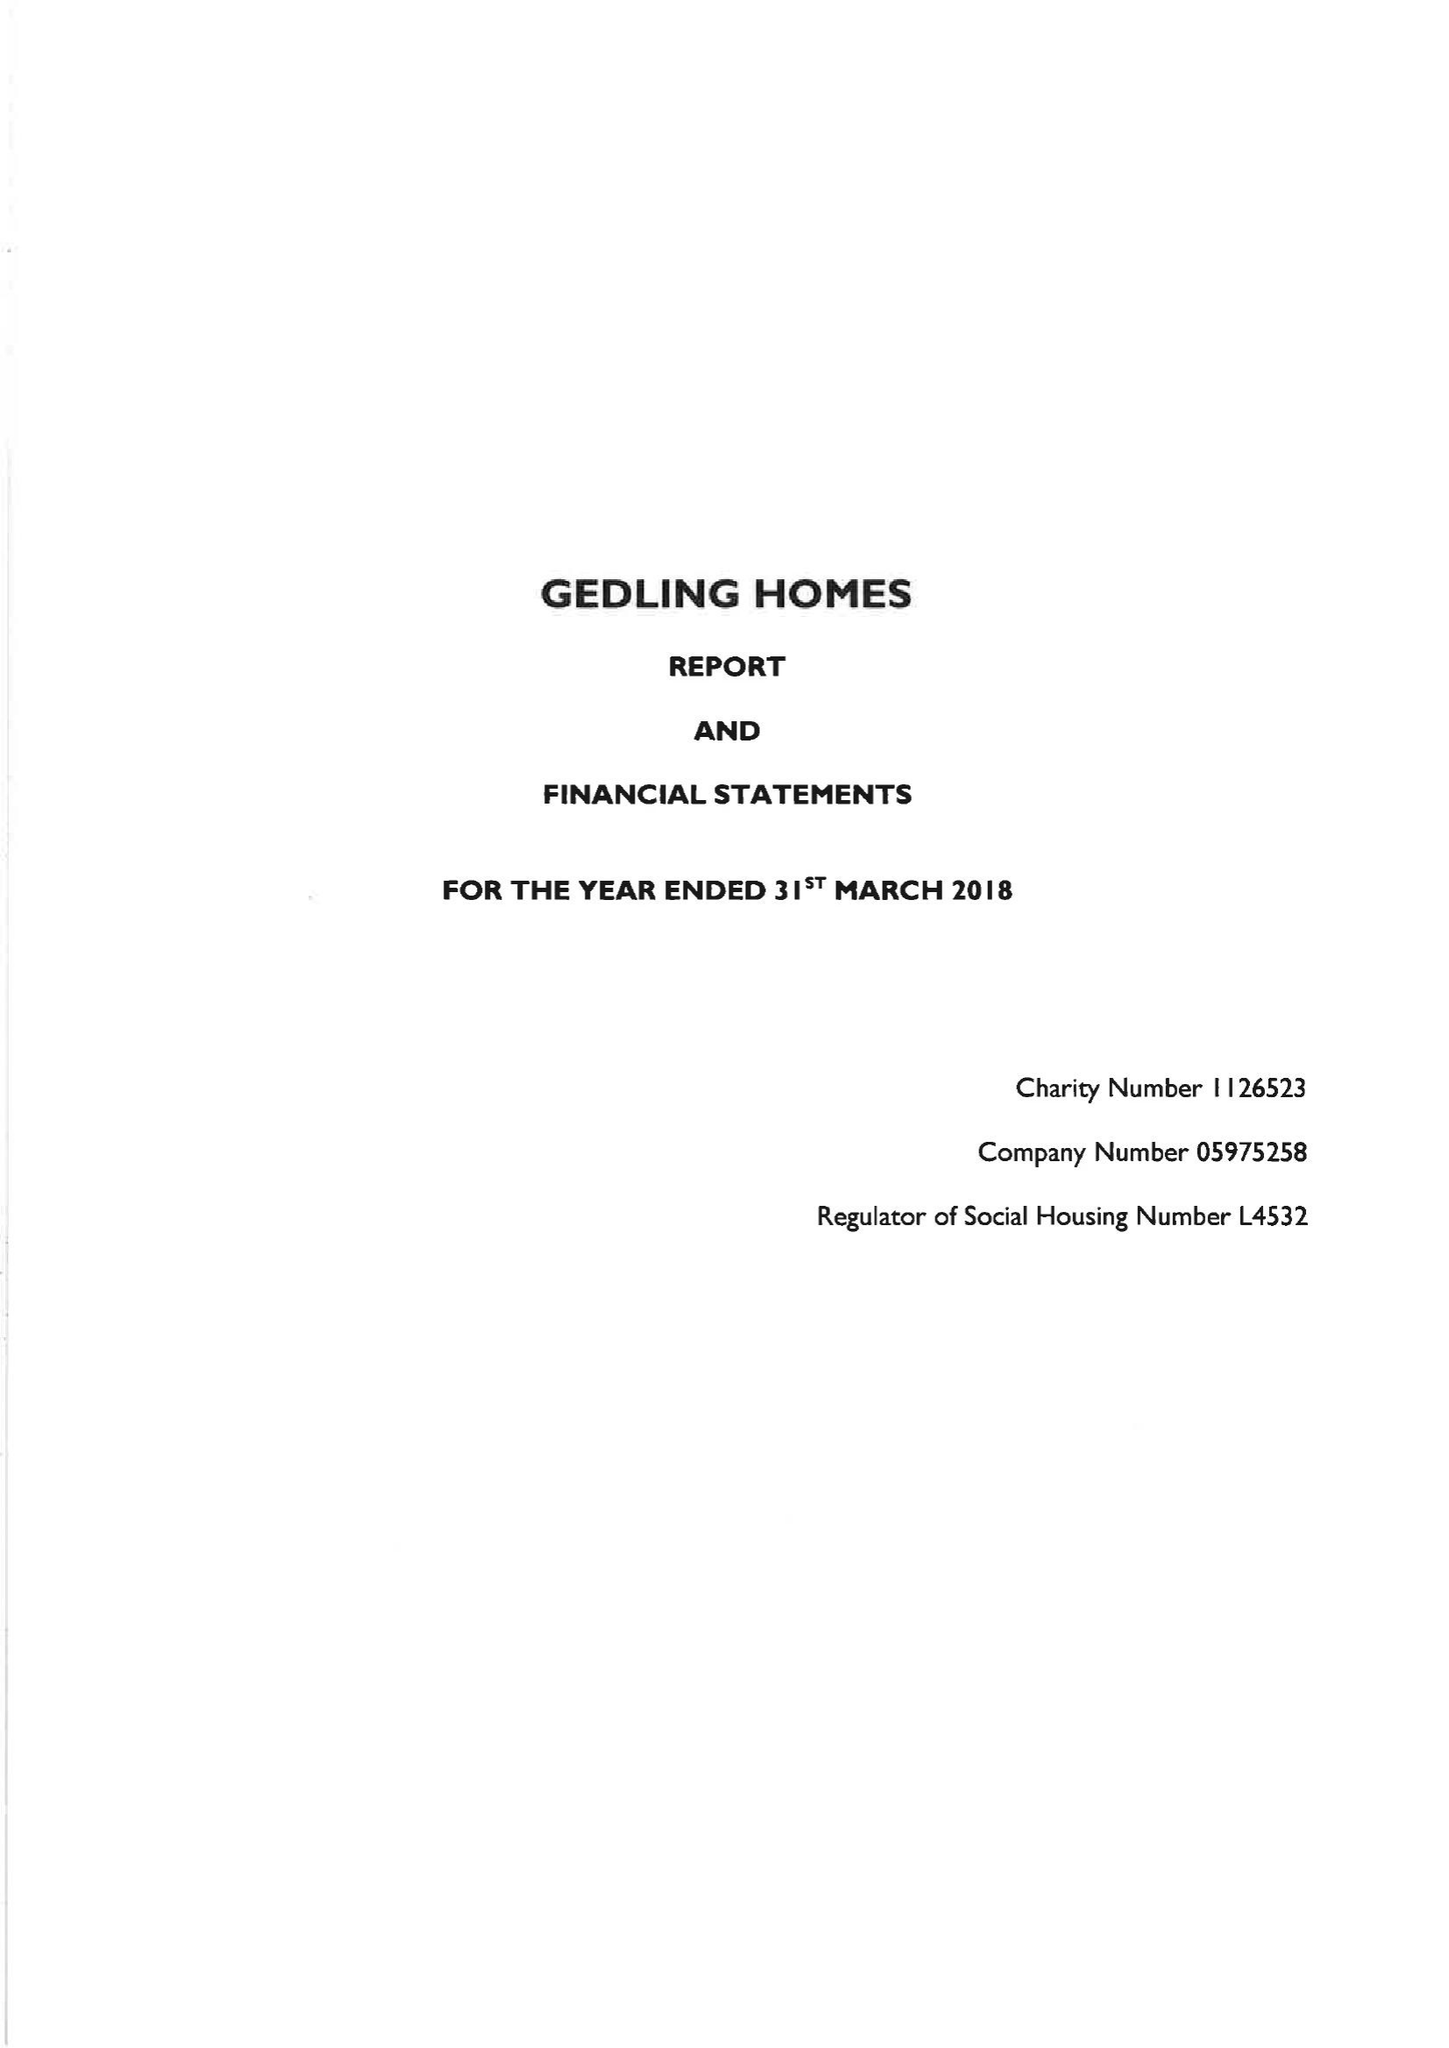What is the value for the spending_annually_in_british_pounds?
Answer the question using a single word or phrase. 12029000.00 